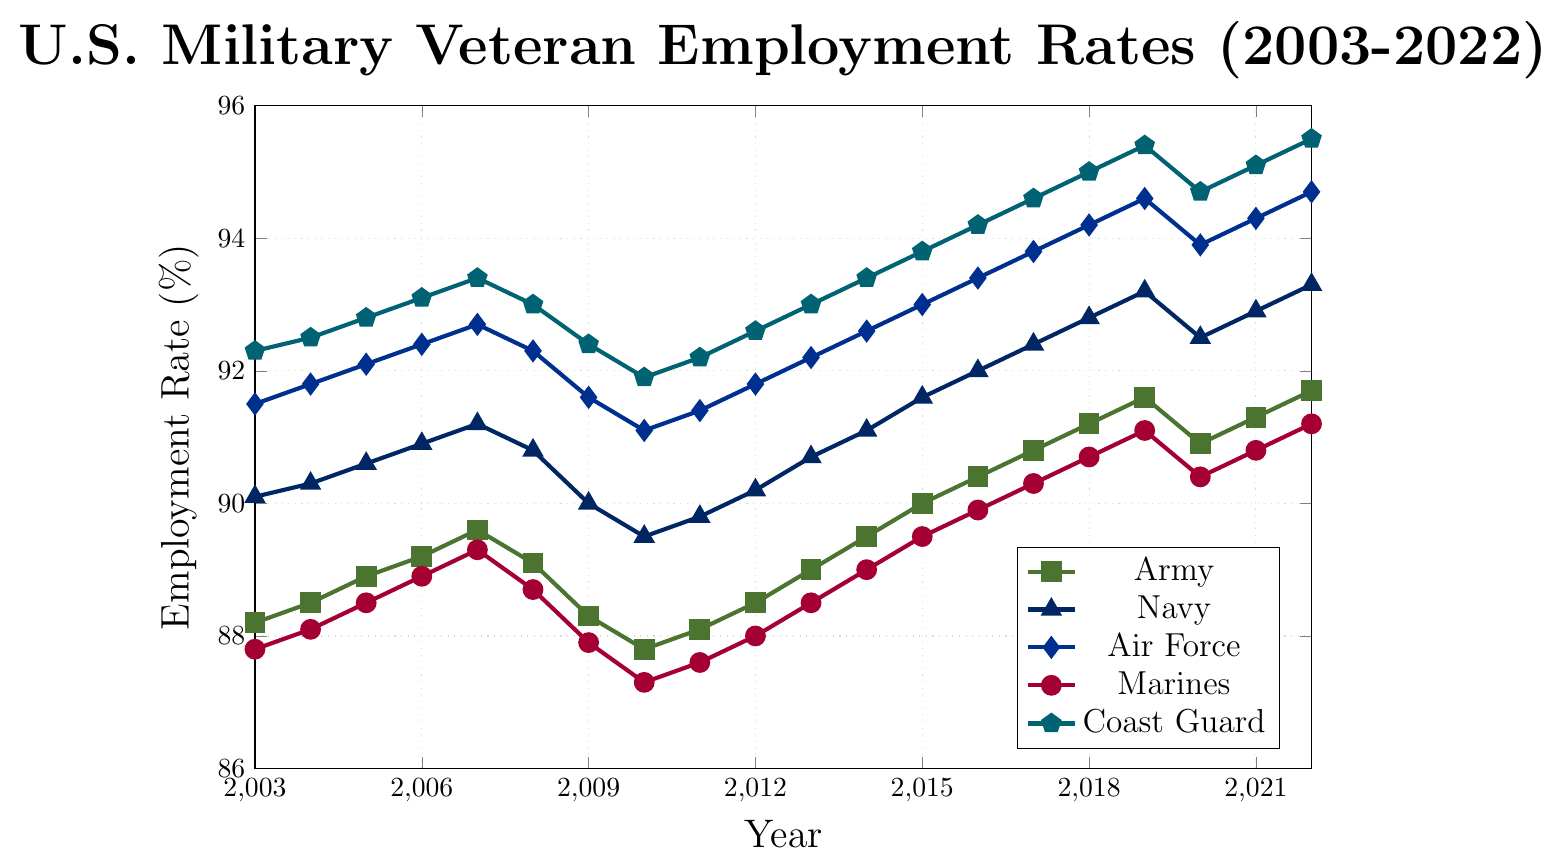Which branch had the highest employment rate in 2022? By visually scanning the endpoints of each line in 2022, the Coast Guard line reaches the highest point on the y-axis.
Answer: Coast Guard Which year did the Army experience the lowest employment rate? By visually examining the lowest point of the Army line (green squares), the lowest point occurs in 2010.
Answer: 2010 Between 2015 and 2017, which branch showed the highest growth in employment rate? By observing the slopes of the lines between 2015 and 2017, the Air Force (blue diamonds) has the steepest positive slope, indicating the highest growth.
Answer: Air Force What is the average employment rate for the Marines from 2008 to 2012? First, identify the Marines' data points from 2008 to 2012 as 88.7, 87.9, 87.3, 87.6, and 88.0. Sum these values and divide by 5: (88.7 + 87.9 + 87.3 + 87.6 + 88.0) / 5 = 439.5 / 5 = 87.9
Answer: 87.9 Which branch had a decreasing employment rate from 2019 to 2020? By checking the slopes of lines from 2019 to 2020, the Army (green squares), Navy (blue triangles), Marines (red circles), and Coast Guard (teal pentagons) have a downward trend.
Answer: Army, Navy, Marines, Coast Guard How much did the Air Force employment rate increase from 2003 to 2022? First, identify the Air Force employment rate in 2003 and 2022, which are 91.5 and 94.7, respectively. The increase is 94.7 - 91.5 = 3.2%.
Answer: 3.2% Between 2006 and 2022, which branch had the most stable employment rate (least fluctuations)? By visually assessing the lines' stability (how flat they are), the Air Force (blue diamonds) appears the most stable with fewer fluctuations.
Answer: Air Force What is the median employment rate for the Coast Guard from 2003 to 2022? List the Coast Guard employment rates: 92.3, 92.5, 92.8, 93.1, 93.4, 93.0, 92.4, 91.9, 92.2, 92.6, 93.0, 93.4, 93.8, 94.2, 94.6, 95.0, 95.4, 94.7, 95.1, 95.5. Sort and find the middle values, (93.4 + 93.8) / 2 = 93.6.
Answer: 93.6 Which branch consistently had employment rates above 90% throughout the period? By visually inspecting the lines, the Navy (blue triangles), Air Force (blue diamonds), and Coast Guard (teal pentagons) stayed above 90% throughout 2003-2022.
Answer: Navy, Air Force, Coast Guard 